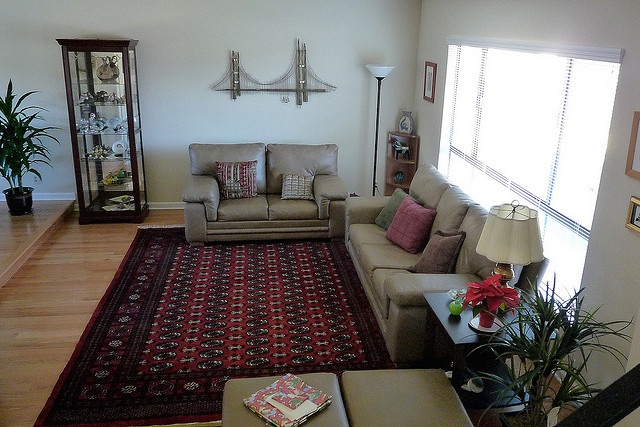Describe the objects in this image and their specific colors. I can see couch in darkgray, gray, and black tones, couch in darkgray, gray, and black tones, potted plant in darkgray, black, gray, and maroon tones, dining table in darkgray, black, and gray tones, and potted plant in darkgray, black, and gray tones in this image. 